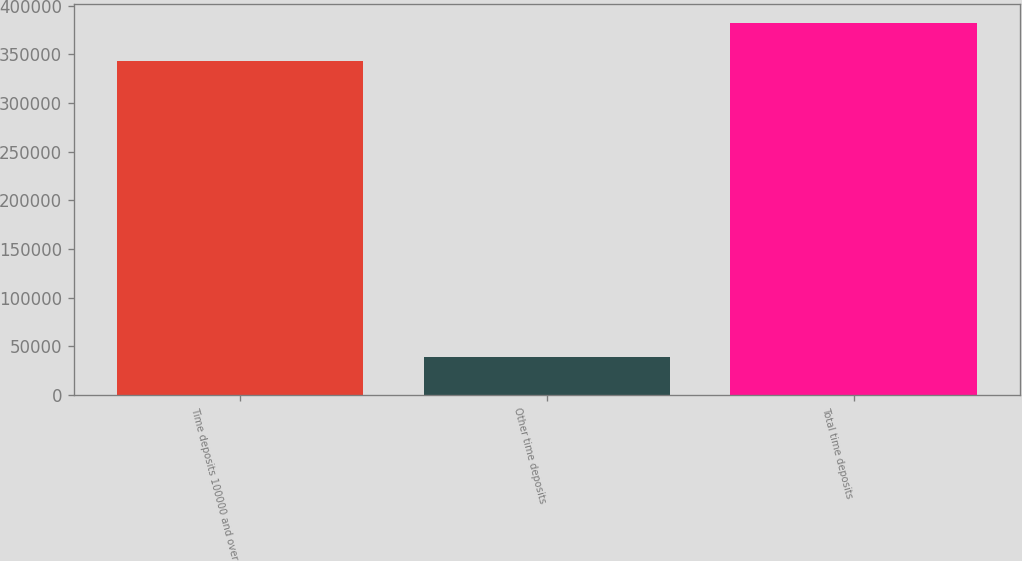Convert chart to OTSL. <chart><loc_0><loc_0><loc_500><loc_500><bar_chart><fcel>Time deposits 100000 and over<fcel>Other time deposits<fcel>Total time deposits<nl><fcel>343533<fcel>39297<fcel>382830<nl></chart> 